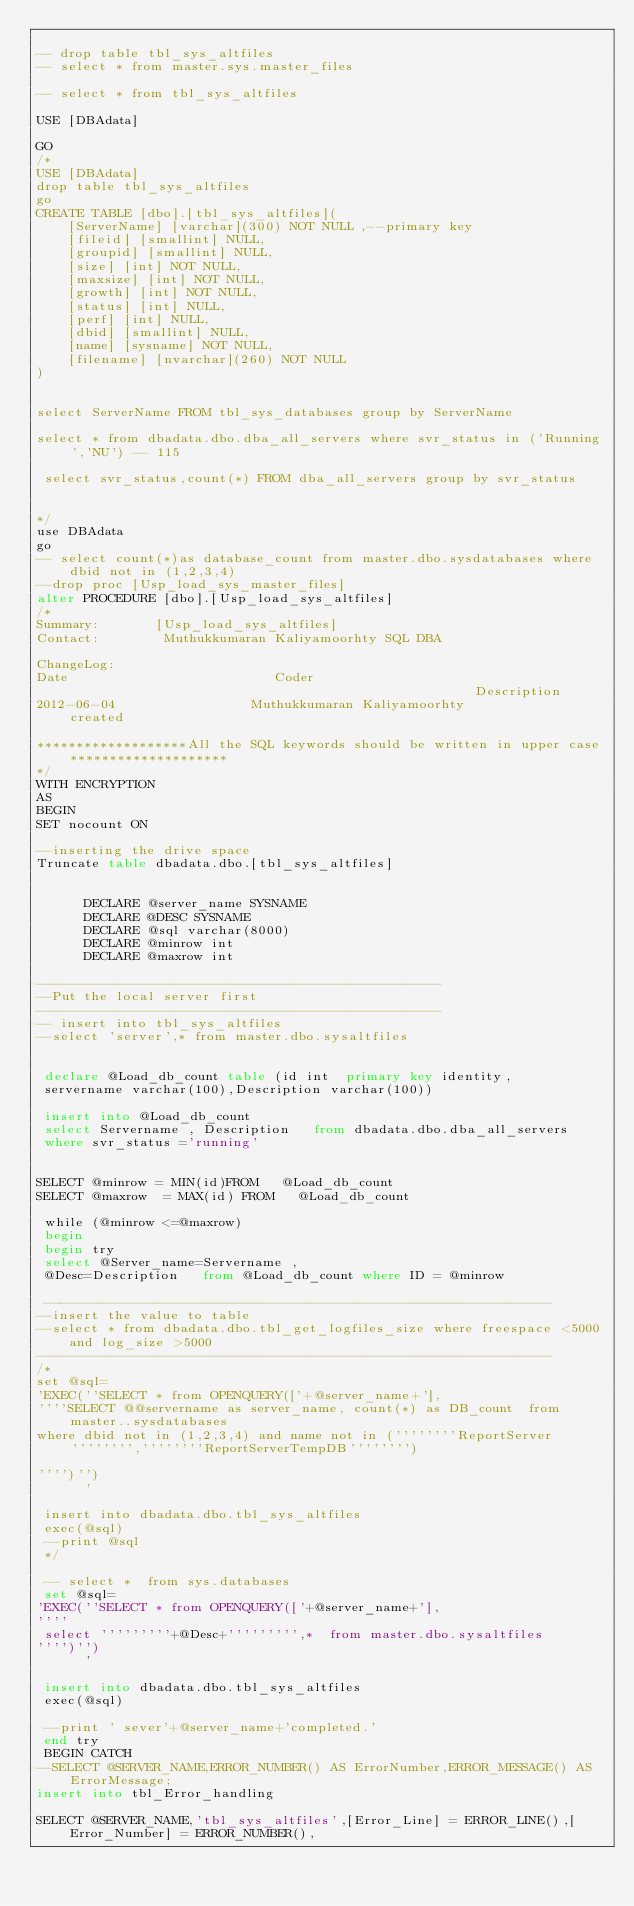Convert code to text. <code><loc_0><loc_0><loc_500><loc_500><_SQL_>
-- drop table tbl_sys_altfiles
-- select * from master.sys.master_files

-- select * from tbl_sys_altfiles

USE [DBAdata]

GO
/*
USE [DBAdata]
drop table tbl_sys_altfiles
go
CREATE TABLE [dbo].[tbl_sys_altfiles](
	[ServerName] [varchar](300) NOT NULL ,--primary key
	[fileid] [smallint] NULL,
	[groupid] [smallint] NULL,
	[size] [int] NOT NULL,
	[maxsize] [int] NOT NULL,
	[growth] [int] NOT NULL,
	[status] [int] NULL,
	[perf] [int] NULL,
	[dbid] [smallint] NULL,
	[name] [sysname] NOT NULL,
	[filename] [nvarchar](260) NOT NULL
) 


select ServerName FROM tbl_sys_databases group by ServerName

select * from dbadata.dbo.dba_all_servers where svr_status in ('Running','NU') -- 115

 select svr_status,count(*) FROM dba_all_servers group by svr_status


*/
use DBAdata
go
-- select count(*)as database_count from master.dbo.sysdatabases where dbid not in (1,2,3,4)
--drop proc [Usp_load_sys_master_files]
alter PROCEDURE [dbo].[Usp_load_sys_altfiles]
/*
Summary:       [Usp_load_sys_altfiles]
Contact:        Muthukkumaran Kaliyamoorhty SQL DBA

ChangeLog:
Date                          Coder                                                    Description
2012-06-04                 Muthukkumaran Kaliyamoorhty               created
 
*******************All the SQL keywords should be written in upper case********************
*/
WITH ENCRYPTION
AS
BEGIN
SET nocount ON

--inserting the drive space
Truncate table dbadata.dbo.[tbl_sys_altfiles]


      DECLARE @server_name SYSNAME
      DECLARE @DESC SYSNAME
      DECLARE @sql varchar(8000)
      DECLARE @minrow int
      DECLARE @maxrow int

---------------------------------------------------
--Put the local server first
---------------------------------------------------
-- insert into tbl_sys_altfiles
--select 'server',* from master.dbo.sysaltfiles


 declare @Load_db_count table (id int  primary key identity, 
 servername varchar(100),Description varchar(100)) 
 
 insert into @Load_db_count
 select Servername , Description   from dbadata.dbo.dba_all_servers 
 where svr_status ='running' 
 
 
SELECT @minrow = MIN(id)FROM   @Load_db_count
SELECT @maxrow  = MAX(id) FROM   @Load_db_count
 
 while (@minrow <=@maxrow)
 begin
 begin try
 select @Server_name=Servername ,
 @Desc=Description   from @Load_db_count where ID = @minrow 
 
 ----------------------------------------------------------------
--insert the value to table
--select * from dbadata.dbo.tbl_get_logfiles_size where freespace <5000 and log_size >5000
-----------------------------------------------------------------
/*
set @sql=
'EXEC(''SELECT * from OPENQUERY(['+@server_name+'],
''''SELECT @@servername as server_name, count(*) as DB_count  from master..sysdatabases 
where dbid not in (1,2,3,4) and name not in (''''''''ReportServer'''''''',''''''''ReportServerTempDB'''''''')
               
'''')'')
      '

 insert into dbadata.dbo.tbl_sys_altfiles
 exec(@sql)
 --print @sql
 */
 
 -- select *  from sys.databases
 set @sql=
'EXEC(''SELECT * from OPENQUERY(['+@server_name+'],
''''
 select '''''''''+@Desc+''''''''',*  from master.dbo.sysaltfiles 
'''')'')
      '

 insert into dbadata.dbo.tbl_sys_altfiles
 exec(@sql)

 --print ' sever'+@server_name+'completed.'
 end try
 BEGIN CATCH
--SELECT @SERVER_NAME,ERROR_NUMBER() AS ErrorNumber,ERROR_MESSAGE() AS ErrorMessage;
insert into tbl_Error_handling
 
SELECT @SERVER_NAME,'tbl_sys_altfiles',[Error_Line] = ERROR_LINE(),[Error_Number] = ERROR_NUMBER(),</code> 